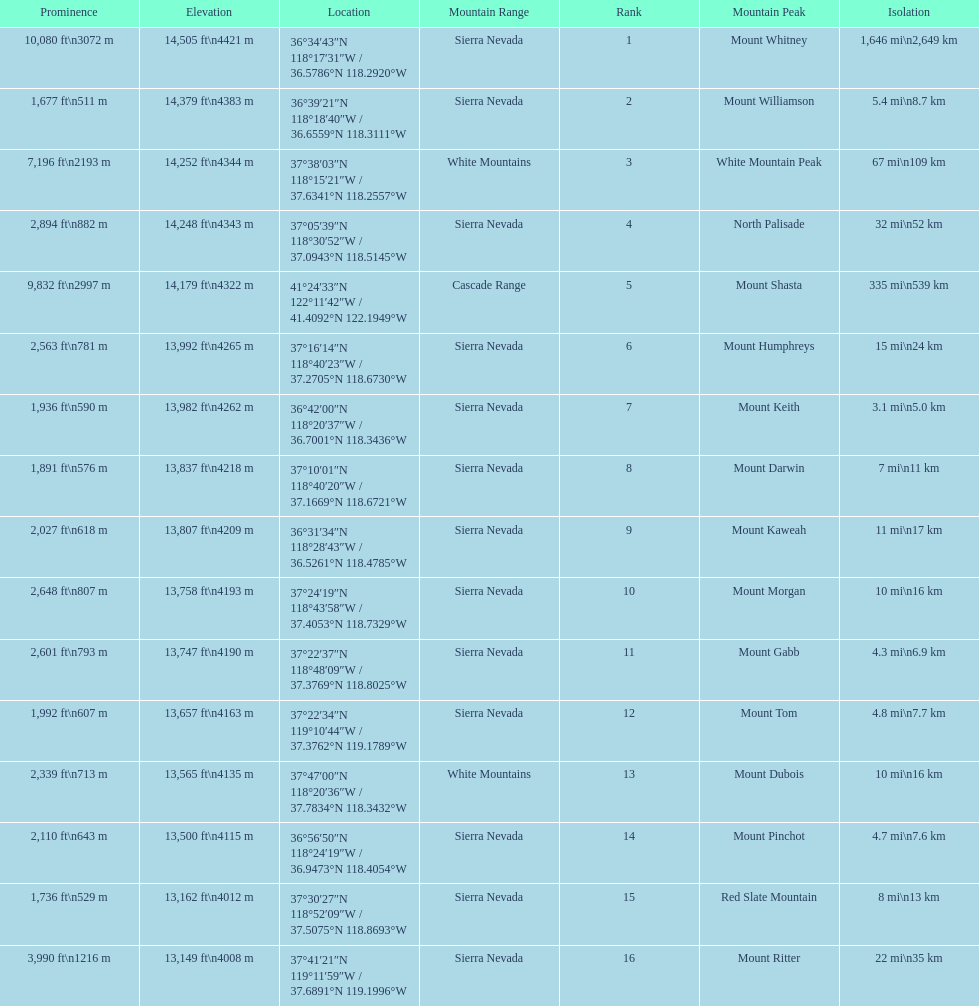Which mountain peak is the only mountain peak in the cascade range? Mount Shasta. 